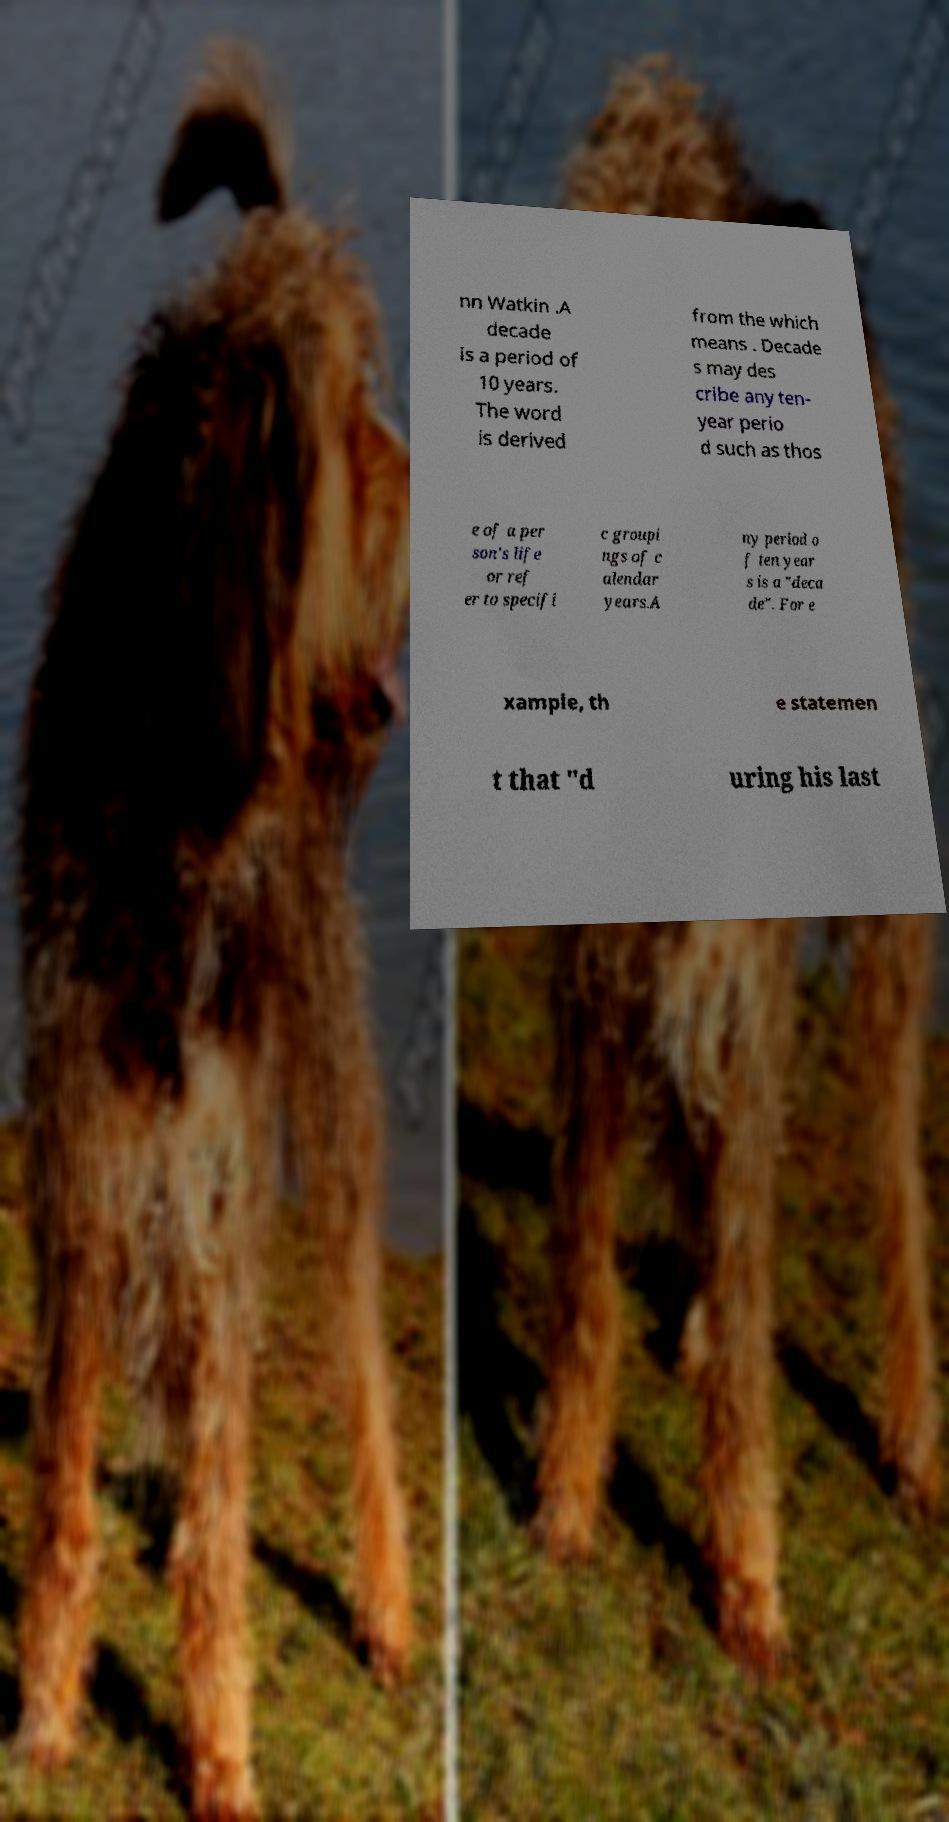For documentation purposes, I need the text within this image transcribed. Could you provide that? nn Watkin .A decade is a period of 10 years. The word is derived from the which means . Decade s may des cribe any ten- year perio d such as thos e of a per son's life or ref er to specifi c groupi ngs of c alendar years.A ny period o f ten year s is a "deca de". For e xample, th e statemen t that "d uring his last 